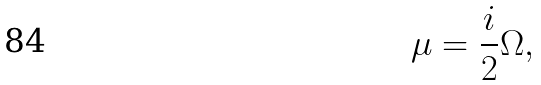Convert formula to latex. <formula><loc_0><loc_0><loc_500><loc_500>\mu = \frac { i } { 2 } \Omega ,</formula> 